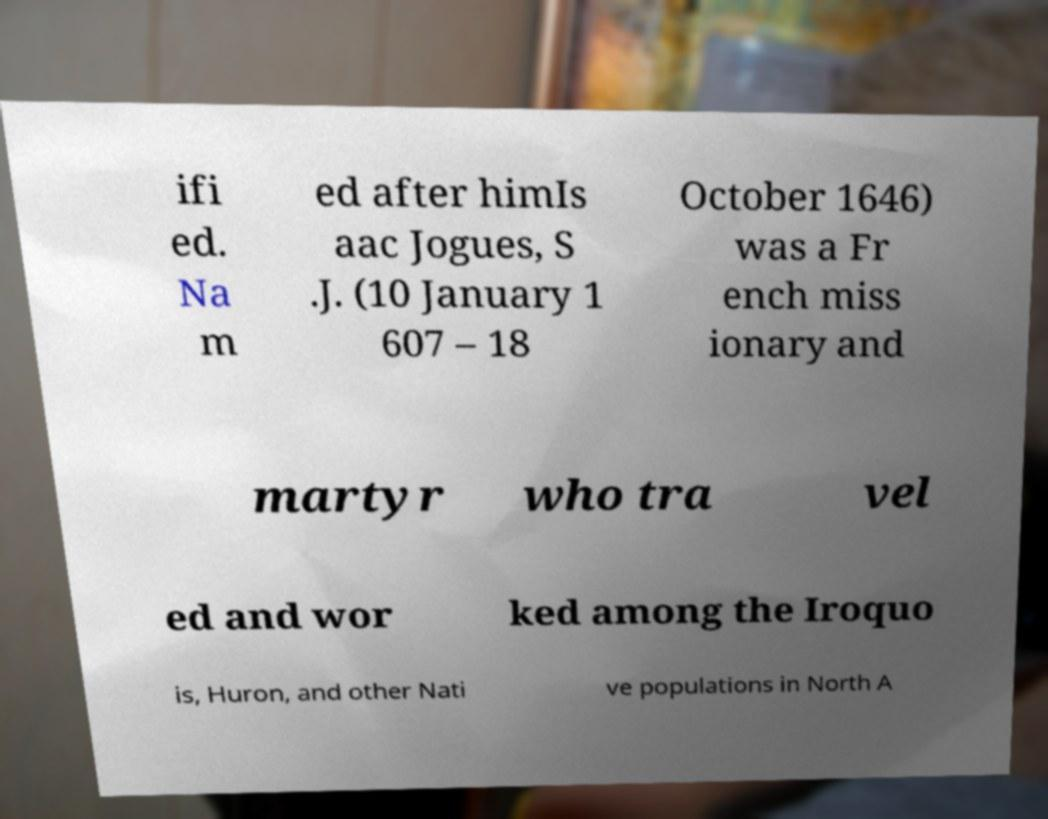Could you assist in decoding the text presented in this image and type it out clearly? ifi ed. Na m ed after himIs aac Jogues, S .J. (10 January 1 607 – 18 October 1646) was a Fr ench miss ionary and martyr who tra vel ed and wor ked among the Iroquo is, Huron, and other Nati ve populations in North A 